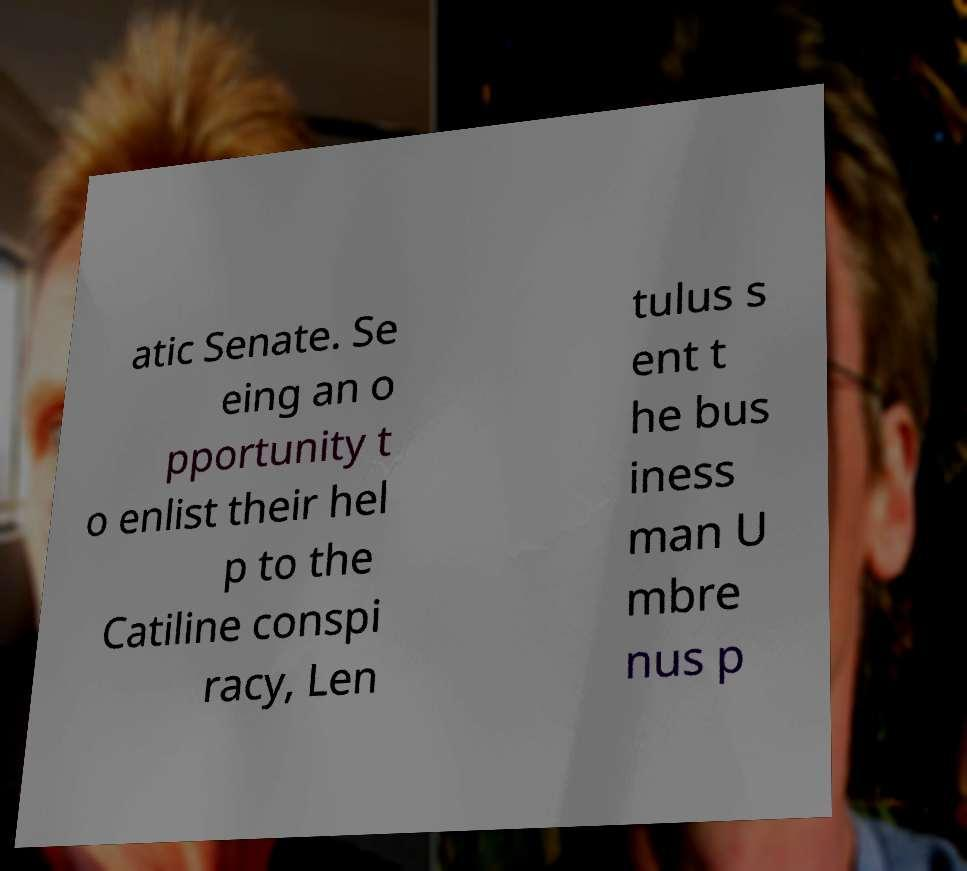Please identify and transcribe the text found in this image. atic Senate. Se eing an o pportunity t o enlist their hel p to the Catiline conspi racy, Len tulus s ent t he bus iness man U mbre nus p 